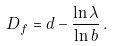Convert formula to latex. <formula><loc_0><loc_0><loc_500><loc_500>D _ { f } = d - { \frac { \ln \lambda } { \ln b } } \, .</formula> 